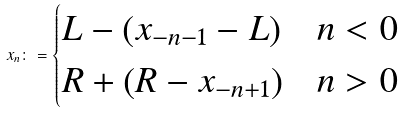Convert formula to latex. <formula><loc_0><loc_0><loc_500><loc_500>x _ { n } \colon = \begin{cases} L - ( x _ { - n - 1 } - L ) & n < 0 \\ R + ( R - x _ { - n + 1 } ) & n > 0 \end{cases}</formula> 